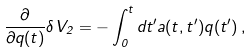<formula> <loc_0><loc_0><loc_500><loc_500>\frac { \partial } { \partial q ( t ) } \delta V _ { 2 } = - \int _ { 0 } ^ { t } d t ^ { \prime } a ( t , t ^ { \prime } ) q ( t ^ { \prime } ) \, ,</formula> 